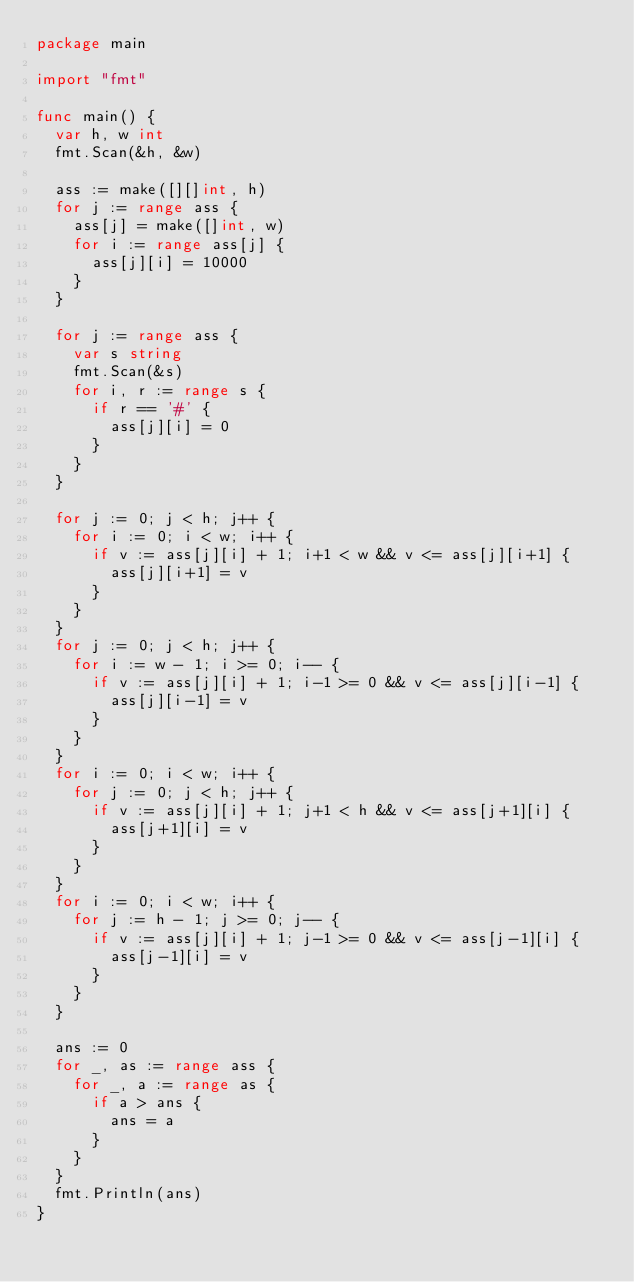Convert code to text. <code><loc_0><loc_0><loc_500><loc_500><_Go_>package main

import "fmt"

func main() {
	var h, w int
	fmt.Scan(&h, &w)

	ass := make([][]int, h)
	for j := range ass {
		ass[j] = make([]int, w)
		for i := range ass[j] {
			ass[j][i] = 10000
		}
	}

	for j := range ass {
		var s string
		fmt.Scan(&s)
		for i, r := range s {
			if r == '#' {
				ass[j][i] = 0
			}
		}
	}

	for j := 0; j < h; j++ {
		for i := 0; i < w; i++ {
			if v := ass[j][i] + 1; i+1 < w && v <= ass[j][i+1] {
				ass[j][i+1] = v
			}
		}
	}
	for j := 0; j < h; j++ {
		for i := w - 1; i >= 0; i-- {
			if v := ass[j][i] + 1; i-1 >= 0 && v <= ass[j][i-1] {
				ass[j][i-1] = v
			}
		}
	}
	for i := 0; i < w; i++ {
		for j := 0; j < h; j++ {
			if v := ass[j][i] + 1; j+1 < h && v <= ass[j+1][i] {
				ass[j+1][i] = v
			}
		}
	}
	for i := 0; i < w; i++ {
		for j := h - 1; j >= 0; j-- {
			if v := ass[j][i] + 1; j-1 >= 0 && v <= ass[j-1][i] {
				ass[j-1][i] = v
			}
		}
	}

	ans := 0
	for _, as := range ass {
		for _, a := range as {
			if a > ans {
				ans = a
			}
		}
	}
	fmt.Println(ans)
}
</code> 